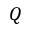Convert formula to latex. <formula><loc_0><loc_0><loc_500><loc_500>Q</formula> 